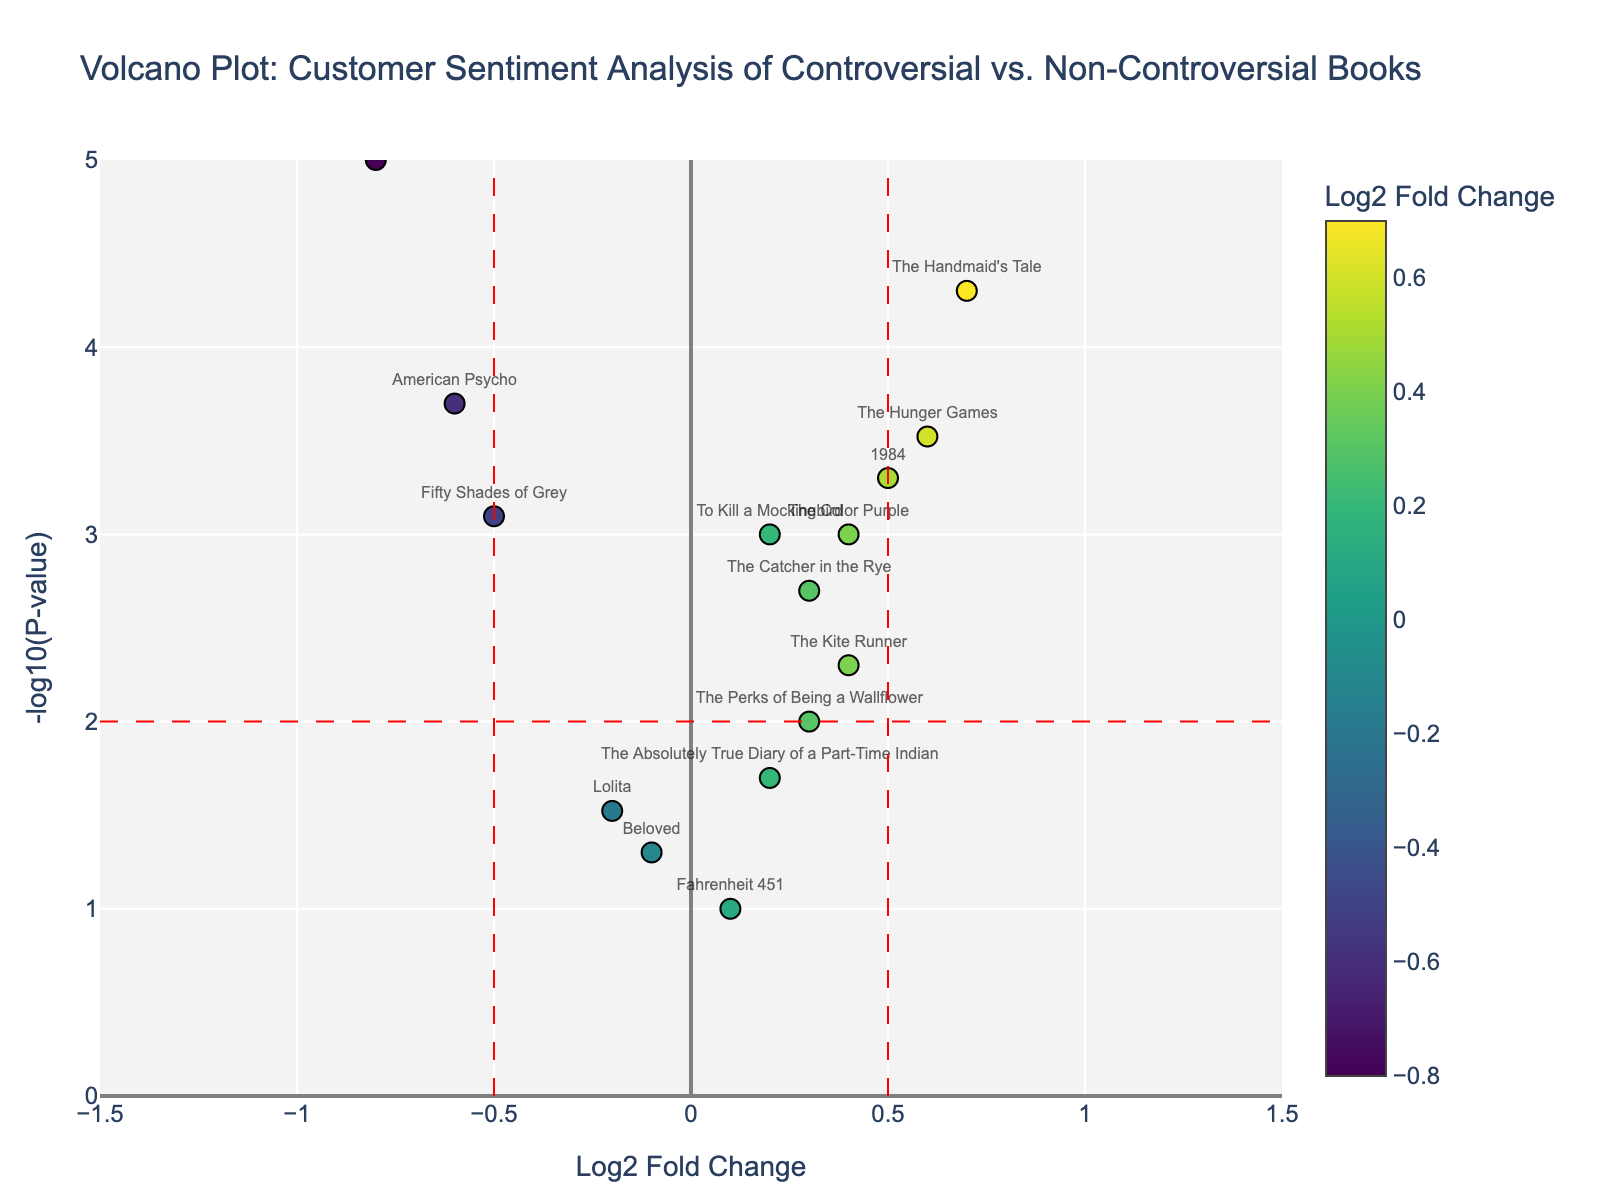How many books fall above the horizontal red line at -log10(P-value) = 2? First, locate the horizontal red line at -log10(P-value) = 2. Count the total number of data points above this line, i.e., with -log10(P-value) greater than 2.
Answer: 9 Which book has the highest -log10(P-value)? Identify the point that reaches the highest y-value on the plot. Check which book title corresponds to it from the hover information.
Answer: "The Satanic Verses" Are there more books with positive Log2 Fold Change values or negative ones? Count the number of books with Log2 Fold Change values greater than 0 (positive) and those with less than 0 (negative). Compare these counts.
Answer: Positive Which book has the lowest Log2 Fold Change, and what is its P-value? Find the point with the lowest x-value (most negative). Hover over this point or read the text annotations to find the book title and its P-value.
Answer: "The Satanic Verses", 0.00001 What is the range of -log10(P-value) for the plotted data? Find the minimum and maximum values on the y-axis where the data points are located. The range will be from the minimum to the maximum -log10(P-value).
Answer: 0 to 5 Which books lie within the vertical red lines at Log2 Fold Change = -0.5 and 0.5? Identify the points located between the two vertical red lines at Log2 Fold Change = -0.5 and 0.5. Check the corresponding book titles for those points.
Answer: "To Kill a Mockingbird", "1984", "The Catcher in the Rye", "Beloved", "The Color Purple", "Fahrenheit 451", "The Perks of Being a Wallflower", "The Absolutely True Diary of a Part-Time Indian", "The Kite Runner" How many books have a P-value less than 0.001? Convert the threshold P-value of 0.001 to -log10 scale which is 3. Identify and count points above the y=3 line.
Answer: 6 Compare the Log2 Fold Change of "American Psycho" and "Lolita". Which book has a more negative sentiment? Find the Log2 Fold Change values for both "American Psycho" and "Lolita". Compare the magnitude of the negative values.
Answer: "American Psycho" (-0.6) has more negative sentiment than "Lolita" (-0.2) What is the Log2 Fold Change for "The Handmaid's Tale", and is it considered a positive or negative sentiment? Locate the plot point for "The Handmaid's Tale" and read its Log2 Fold Change. Determine whether it is positive or negative.
Answer: "The Handmaid's Tale" has a Log2 Fold Change of 0.7, which is positive 